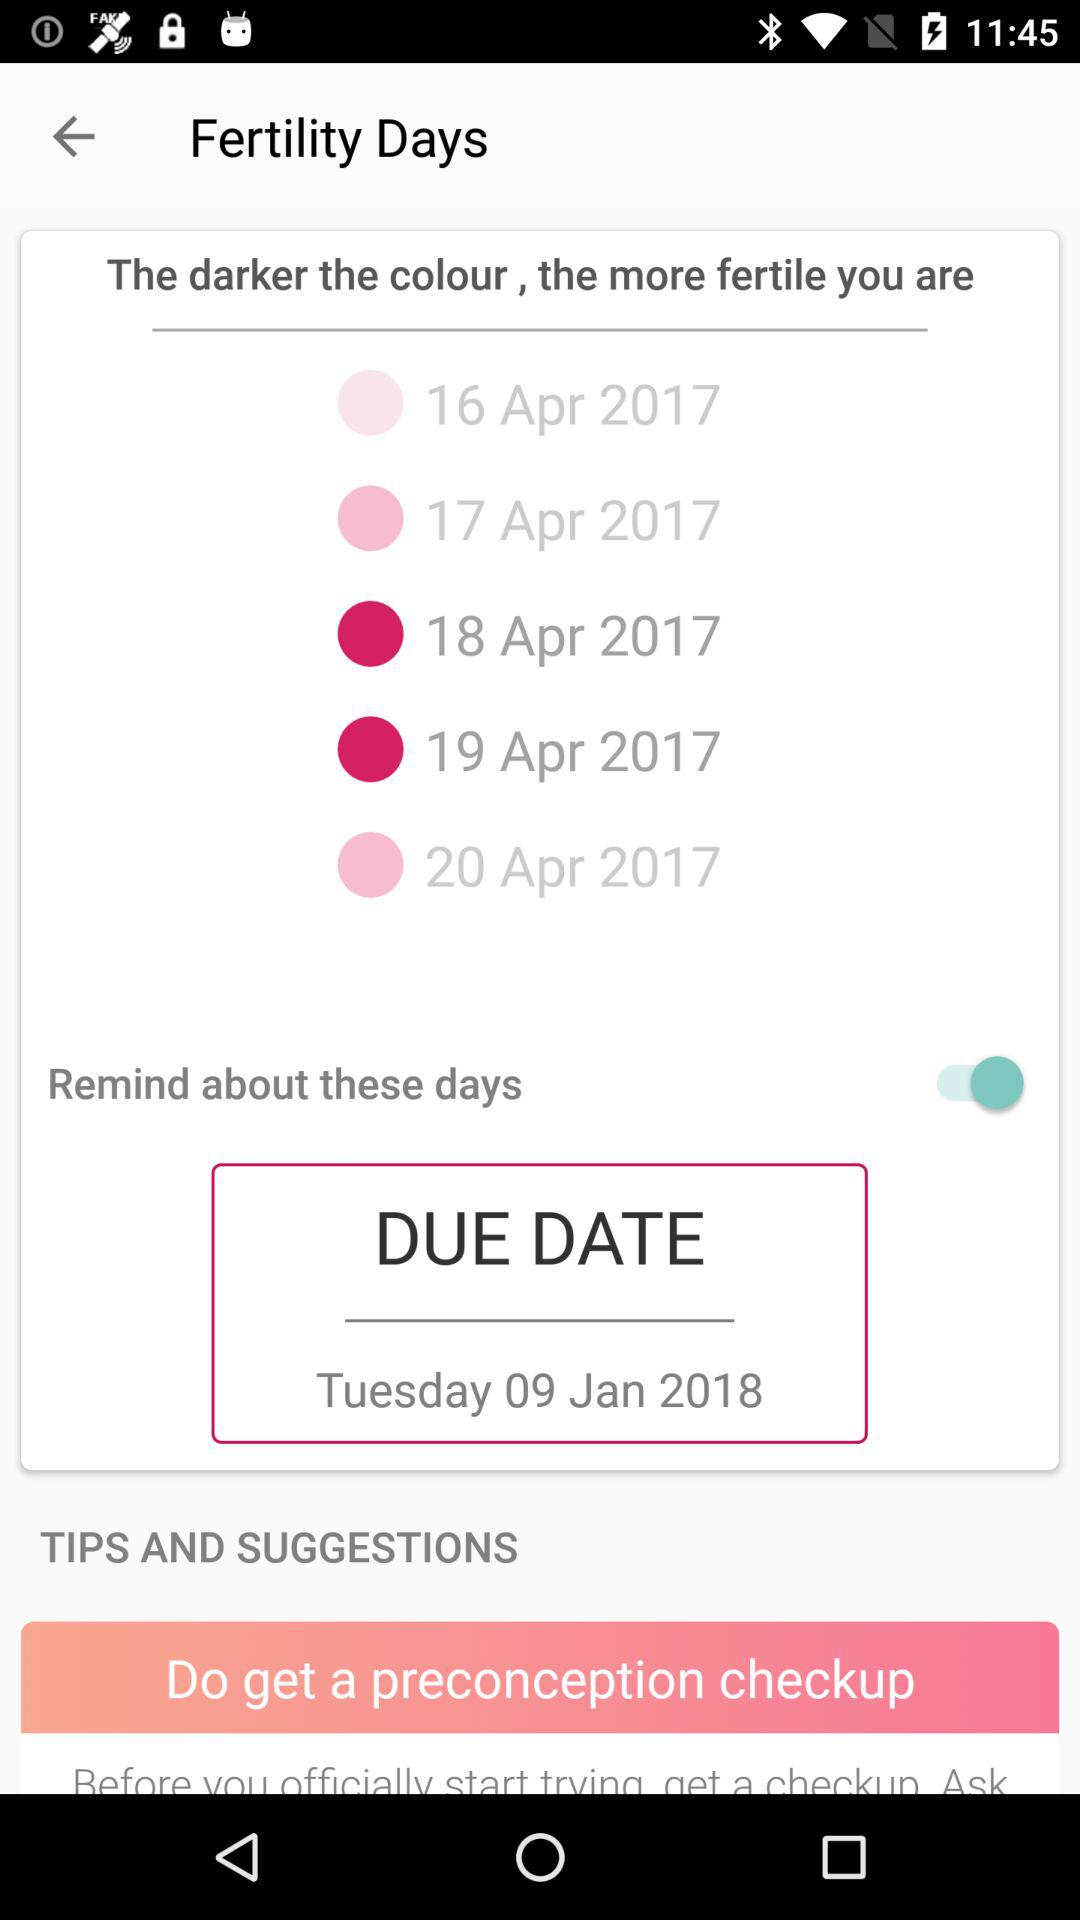How many fertility days are there in total?
Answer the question using a single word or phrase. 5 